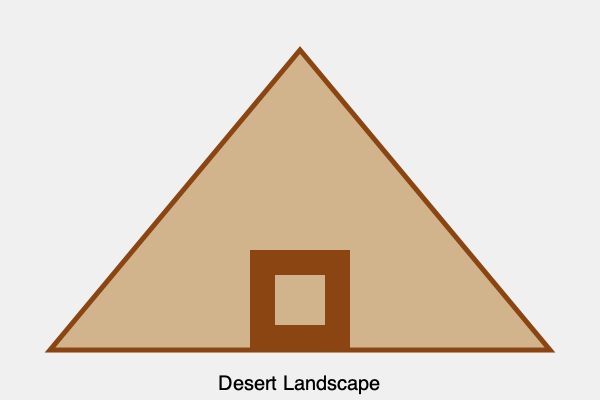Which UNESCO World Heritage Site, known for its ancient pyramids and sphinx, does this simplified graphic represent? To identify the UNESCO World Heritage Site represented by this graphic, let's analyze its key features:

1. The large triangular shape in the center represents a pyramid, which is the most iconic feature of this site.
2. The rectangular structure at the base of the pyramid could represent ancient Egyptian architecture or temples.
3. The desert landscape, indicated by the sandy color and the text at the bottom, suggests a location in a hot, arid region.
4. The combination of pyramids and desert immediately points to Egypt.

Given these elements, we can deduce that this graphic is a simplified representation of the Giza Pyramid Complex, which includes:

- The Great Pyramid of Giza (largest pyramid)
- The Pyramid of Khafre
- The Pyramid of Menkaure
- The Great Sphinx of Giza (not directly shown in this simplified graphic)

This complex is located on the Giza Plateau, near Cairo, Egypt. It was inscribed as a UNESCO World Heritage Site in 1979 under the name "Memphis and its Necropolis – the Pyramid Fields from Giza to Dahshur."

The Giza Pyramid Complex is one of the most recognizable and visited historical sites in the world, making it a prime destination for tourists interested in world-renowned museums and historical sites.
Answer: Giza Pyramid Complex 